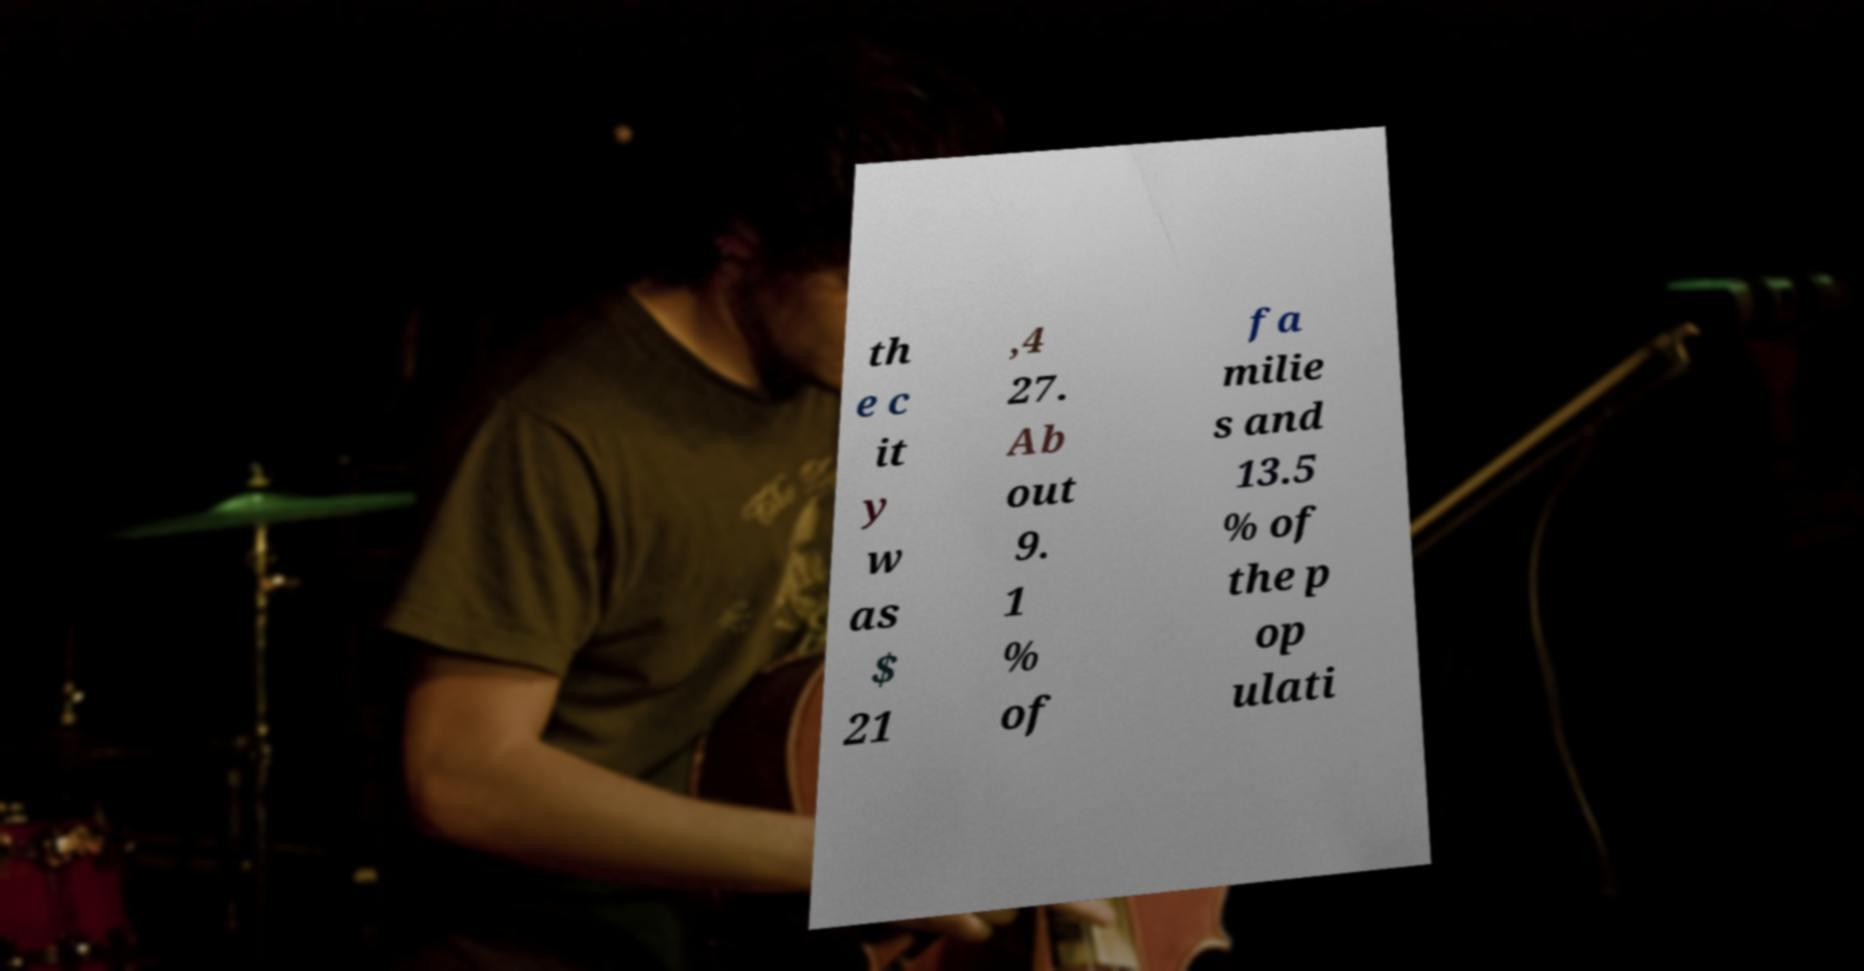Could you extract and type out the text from this image? th e c it y w as $ 21 ,4 27. Ab out 9. 1 % of fa milie s and 13.5 % of the p op ulati 